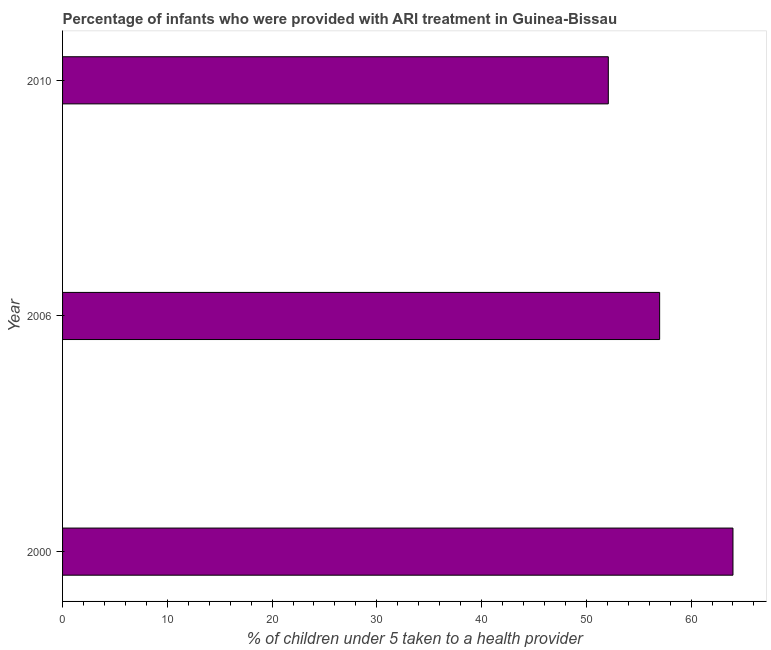Does the graph contain any zero values?
Provide a short and direct response. No. What is the title of the graph?
Make the answer very short. Percentage of infants who were provided with ARI treatment in Guinea-Bissau. What is the label or title of the X-axis?
Your answer should be very brief. % of children under 5 taken to a health provider. What is the label or title of the Y-axis?
Your answer should be compact. Year. What is the percentage of children who were provided with ari treatment in 2010?
Your response must be concise. 52.1. Across all years, what is the minimum percentage of children who were provided with ari treatment?
Give a very brief answer. 52.1. In which year was the percentage of children who were provided with ari treatment maximum?
Offer a terse response. 2000. In which year was the percentage of children who were provided with ari treatment minimum?
Offer a terse response. 2010. What is the sum of the percentage of children who were provided with ari treatment?
Keep it short and to the point. 173.1. What is the difference between the percentage of children who were provided with ari treatment in 2000 and 2006?
Offer a terse response. 7. What is the average percentage of children who were provided with ari treatment per year?
Provide a short and direct response. 57.7. What is the median percentage of children who were provided with ari treatment?
Make the answer very short. 57. What is the ratio of the percentage of children who were provided with ari treatment in 2006 to that in 2010?
Your response must be concise. 1.09. Is the difference between the percentage of children who were provided with ari treatment in 2000 and 2006 greater than the difference between any two years?
Ensure brevity in your answer.  No. Is the sum of the percentage of children who were provided with ari treatment in 2000 and 2010 greater than the maximum percentage of children who were provided with ari treatment across all years?
Your answer should be very brief. Yes. What is the difference between two consecutive major ticks on the X-axis?
Offer a terse response. 10. Are the values on the major ticks of X-axis written in scientific E-notation?
Your answer should be very brief. No. What is the % of children under 5 taken to a health provider of 2000?
Your answer should be very brief. 64. What is the % of children under 5 taken to a health provider in 2006?
Your answer should be compact. 57. What is the % of children under 5 taken to a health provider of 2010?
Your answer should be very brief. 52.1. What is the ratio of the % of children under 5 taken to a health provider in 2000 to that in 2006?
Provide a succinct answer. 1.12. What is the ratio of the % of children under 5 taken to a health provider in 2000 to that in 2010?
Keep it short and to the point. 1.23. What is the ratio of the % of children under 5 taken to a health provider in 2006 to that in 2010?
Give a very brief answer. 1.09. 